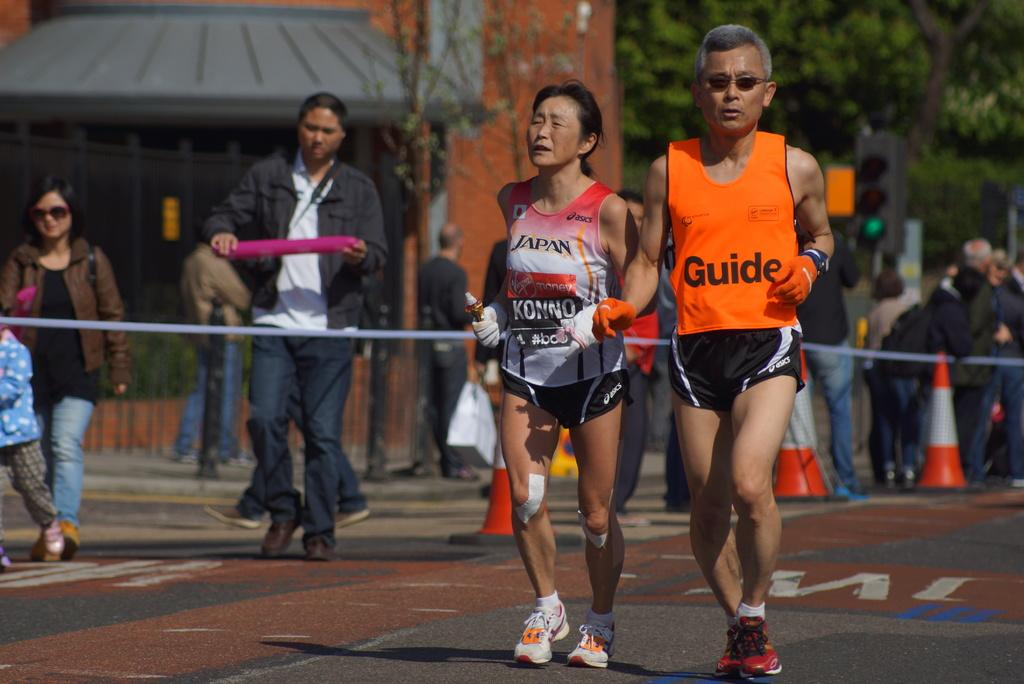<image>
Describe the image concisely. A man is running with a shirt on with the word guide on it. 